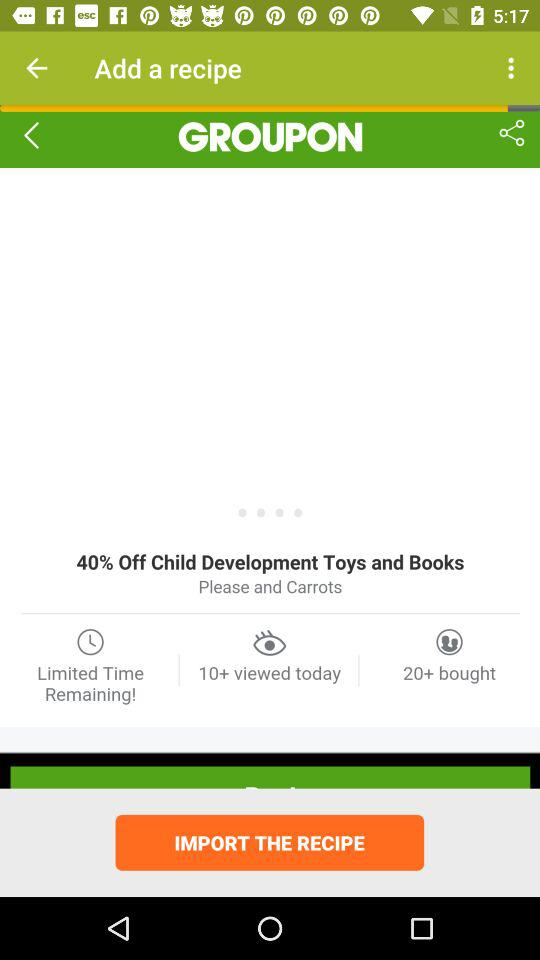How many more people have bought this recipe than viewed it?
Answer the question using a single word or phrase. 10 